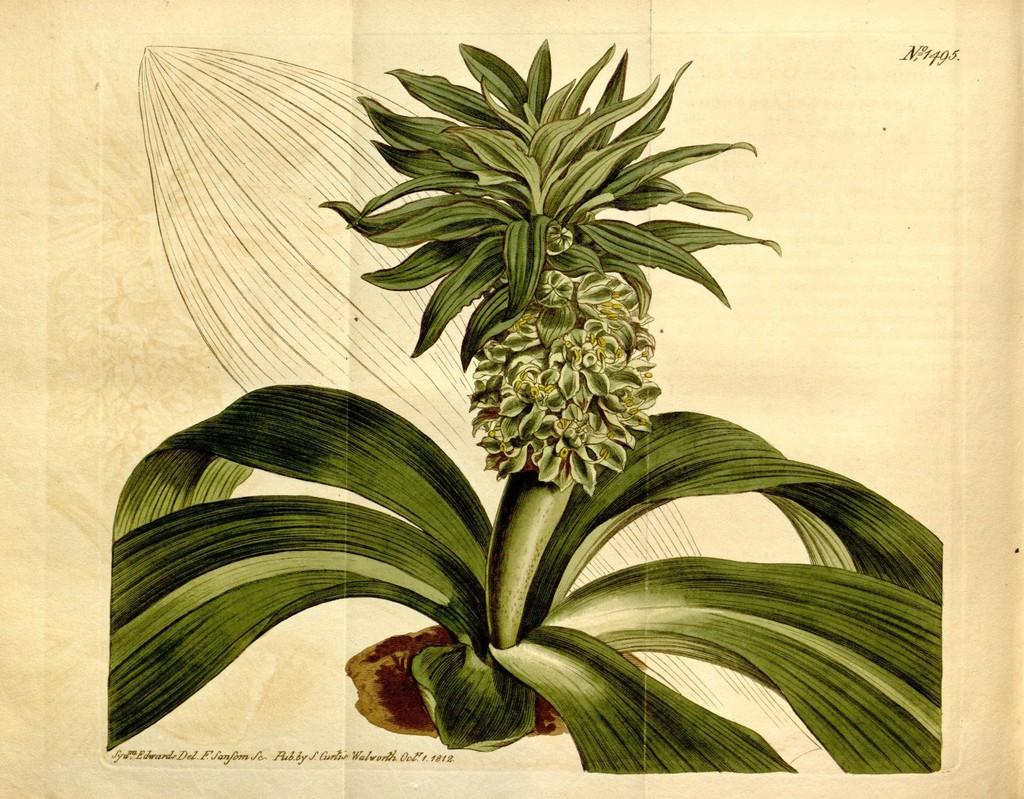What is the main subject of the picture? The main subject of the picture is an image of a plant. What type of motion does the plant exhibit in the picture? The plant does not exhibit any motion in the picture, as it is a static image. Who is the partner of the plant in the picture? There is no partner present in the picture, as it only features an image of a plant. 